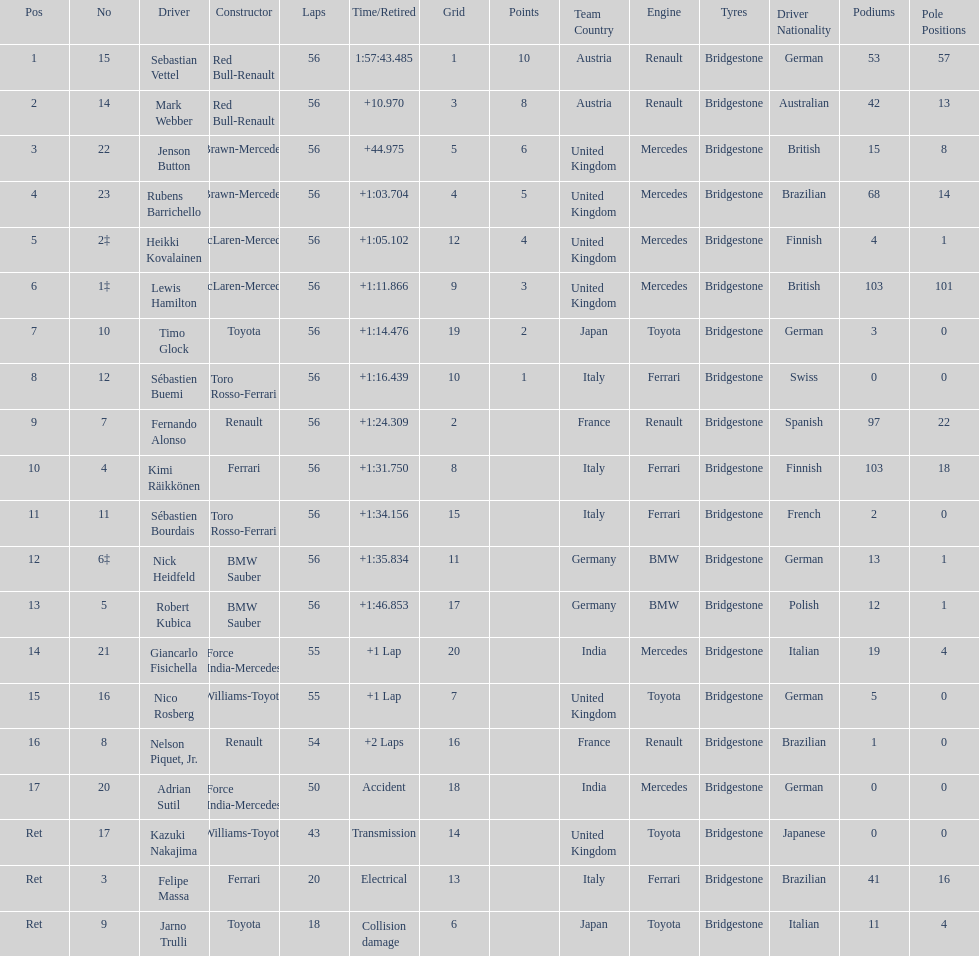Could you parse the entire table? {'header': ['Pos', 'No', 'Driver', 'Constructor', 'Laps', 'Time/Retired', 'Grid', 'Points', 'Team Country', 'Engine', 'Tyres', 'Driver Nationality', 'Podiums', 'Pole Positions'], 'rows': [['1', '15', 'Sebastian Vettel', 'Red Bull-Renault', '56', '1:57:43.485', '1', '10', 'Austria', 'Renault', 'Bridgestone', 'German', '53', '57'], ['2', '14', 'Mark Webber', 'Red Bull-Renault', '56', '+10.970', '3', '8', 'Austria', 'Renault', 'Bridgestone', 'Australian', '42', '13'], ['3', '22', 'Jenson Button', 'Brawn-Mercedes', '56', '+44.975', '5', '6', 'United Kingdom', 'Mercedes', 'Bridgestone', 'British', '15', '8'], ['4', '23', 'Rubens Barrichello', 'Brawn-Mercedes', '56', '+1:03.704', '4', '5', 'United Kingdom', 'Mercedes', 'Bridgestone', 'Brazilian', '68', '14'], ['5', '2‡', 'Heikki Kovalainen', 'McLaren-Mercedes', '56', '+1:05.102', '12', '4', 'United Kingdom', 'Mercedes', 'Bridgestone', 'Finnish', '4', '1'], ['6', '1‡', 'Lewis Hamilton', 'McLaren-Mercedes', '56', '+1:11.866', '9', '3', 'United Kingdom', 'Mercedes', 'Bridgestone', 'British', '103', '101'], ['7', '10', 'Timo Glock', 'Toyota', '56', '+1:14.476', '19', '2', 'Japan', 'Toyota', 'Bridgestone', 'German', '3', '0'], ['8', '12', 'Sébastien Buemi', 'Toro Rosso-Ferrari', '56', '+1:16.439', '10', '1', 'Italy', 'Ferrari', 'Bridgestone', 'Swiss', '0', '0'], ['9', '7', 'Fernando Alonso', 'Renault', '56', '+1:24.309', '2', '', 'France', 'Renault', 'Bridgestone', 'Spanish', '97', '22'], ['10', '4', 'Kimi Räikkönen', 'Ferrari', '56', '+1:31.750', '8', '', 'Italy', 'Ferrari', 'Bridgestone', 'Finnish', '103', '18'], ['11', '11', 'Sébastien Bourdais', 'Toro Rosso-Ferrari', '56', '+1:34.156', '15', '', 'Italy', 'Ferrari', 'Bridgestone', 'French', '2', '0'], ['12', '6‡', 'Nick Heidfeld', 'BMW Sauber', '56', '+1:35.834', '11', '', 'Germany', 'BMW', 'Bridgestone', 'German', '13', '1'], ['13', '5', 'Robert Kubica', 'BMW Sauber', '56', '+1:46.853', '17', '', 'Germany', 'BMW', 'Bridgestone', 'Polish', '12', '1'], ['14', '21', 'Giancarlo Fisichella', 'Force India-Mercedes', '55', '+1 Lap', '20', '', 'India', 'Mercedes', 'Bridgestone', 'Italian', '19', '4'], ['15', '16', 'Nico Rosberg', 'Williams-Toyota', '55', '+1 Lap', '7', '', 'United Kingdom', 'Toyota', 'Bridgestone', 'German', '5', '0'], ['16', '8', 'Nelson Piquet, Jr.', 'Renault', '54', '+2 Laps', '16', '', 'France', 'Renault', 'Bridgestone', 'Brazilian', '1', '0'], ['17', '20', 'Adrian Sutil', 'Force India-Mercedes', '50', 'Accident', '18', '', 'India', 'Mercedes', 'Bridgestone', 'German', '0', '0'], ['Ret', '17', 'Kazuki Nakajima', 'Williams-Toyota', '43', 'Transmission', '14', '', 'United Kingdom', 'Toyota', 'Bridgestone', 'Japanese', '0', '0'], ['Ret', '3', 'Felipe Massa', 'Ferrari', '20', 'Electrical', '13', '', 'Italy', 'Ferrari', 'Bridgestone', 'Brazilian', '41', '16'], ['Ret', '9', 'Jarno Trulli', 'Toyota', '18', 'Collision damage', '6', '', 'Japan', 'Toyota', 'Bridgestone', 'Italian', '11', '4']]} Who was the slowest driver to finish the race? Robert Kubica. 